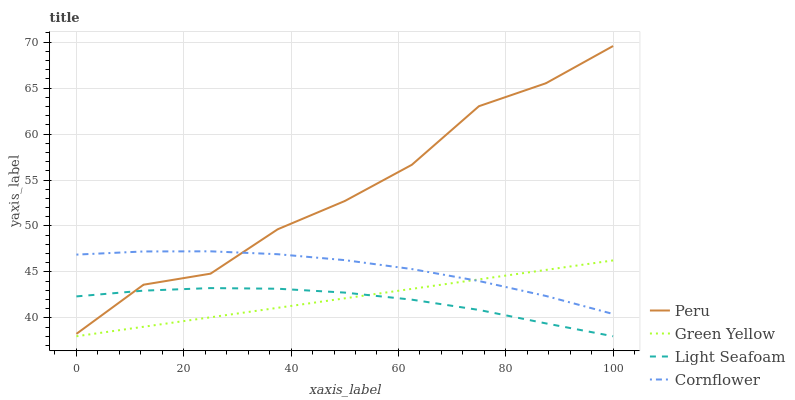Does Light Seafoam have the minimum area under the curve?
Answer yes or no. Yes. Does Peru have the maximum area under the curve?
Answer yes or no. Yes. Does Cornflower have the minimum area under the curve?
Answer yes or no. No. Does Cornflower have the maximum area under the curve?
Answer yes or no. No. Is Green Yellow the smoothest?
Answer yes or no. Yes. Is Peru the roughest?
Answer yes or no. Yes. Is Cornflower the smoothest?
Answer yes or no. No. Is Cornflower the roughest?
Answer yes or no. No. Does Light Seafoam have the lowest value?
Answer yes or no. Yes. Does Cornflower have the lowest value?
Answer yes or no. No. Does Peru have the highest value?
Answer yes or no. Yes. Does Cornflower have the highest value?
Answer yes or no. No. Is Green Yellow less than Peru?
Answer yes or no. Yes. Is Peru greater than Green Yellow?
Answer yes or no. Yes. Does Light Seafoam intersect Green Yellow?
Answer yes or no. Yes. Is Light Seafoam less than Green Yellow?
Answer yes or no. No. Is Light Seafoam greater than Green Yellow?
Answer yes or no. No. Does Green Yellow intersect Peru?
Answer yes or no. No. 